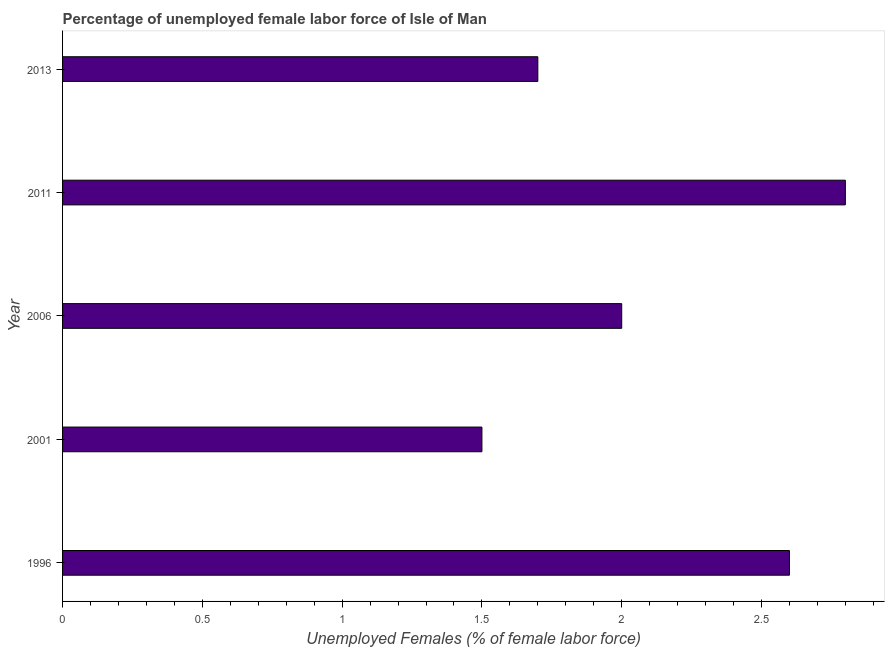What is the title of the graph?
Offer a very short reply. Percentage of unemployed female labor force of Isle of Man. What is the label or title of the X-axis?
Keep it short and to the point. Unemployed Females (% of female labor force). What is the total unemployed female labour force in 1996?
Provide a short and direct response. 2.6. Across all years, what is the maximum total unemployed female labour force?
Keep it short and to the point. 2.8. Across all years, what is the minimum total unemployed female labour force?
Provide a short and direct response. 1.5. In which year was the total unemployed female labour force maximum?
Provide a succinct answer. 2011. What is the sum of the total unemployed female labour force?
Provide a short and direct response. 10.6. What is the difference between the total unemployed female labour force in 1996 and 2001?
Give a very brief answer. 1.1. What is the average total unemployed female labour force per year?
Your response must be concise. 2.12. What is the ratio of the total unemployed female labour force in 2006 to that in 2011?
Make the answer very short. 0.71. Is the total unemployed female labour force in 2011 less than that in 2013?
Your response must be concise. No. Is the difference between the total unemployed female labour force in 1996 and 2001 greater than the difference between any two years?
Your answer should be very brief. No. Is the sum of the total unemployed female labour force in 2011 and 2013 greater than the maximum total unemployed female labour force across all years?
Offer a very short reply. Yes. In how many years, is the total unemployed female labour force greater than the average total unemployed female labour force taken over all years?
Provide a succinct answer. 2. How many bars are there?
Your answer should be very brief. 5. Are all the bars in the graph horizontal?
Your answer should be compact. Yes. What is the difference between two consecutive major ticks on the X-axis?
Offer a very short reply. 0.5. What is the Unemployed Females (% of female labor force) of 1996?
Offer a very short reply. 2.6. What is the Unemployed Females (% of female labor force) of 2011?
Your answer should be very brief. 2.8. What is the Unemployed Females (% of female labor force) of 2013?
Provide a succinct answer. 1.7. What is the difference between the Unemployed Females (% of female labor force) in 1996 and 2001?
Ensure brevity in your answer.  1.1. What is the difference between the Unemployed Females (% of female labor force) in 1996 and 2006?
Provide a short and direct response. 0.6. What is the difference between the Unemployed Females (% of female labor force) in 1996 and 2011?
Give a very brief answer. -0.2. What is the difference between the Unemployed Females (% of female labor force) in 2001 and 2006?
Your response must be concise. -0.5. What is the difference between the Unemployed Females (% of female labor force) in 2001 and 2011?
Keep it short and to the point. -1.3. What is the difference between the Unemployed Females (% of female labor force) in 2006 and 2011?
Provide a succinct answer. -0.8. What is the difference between the Unemployed Females (% of female labor force) in 2006 and 2013?
Your answer should be compact. 0.3. What is the difference between the Unemployed Females (% of female labor force) in 2011 and 2013?
Provide a succinct answer. 1.1. What is the ratio of the Unemployed Females (% of female labor force) in 1996 to that in 2001?
Your answer should be compact. 1.73. What is the ratio of the Unemployed Females (% of female labor force) in 1996 to that in 2011?
Keep it short and to the point. 0.93. What is the ratio of the Unemployed Females (% of female labor force) in 1996 to that in 2013?
Offer a very short reply. 1.53. What is the ratio of the Unemployed Females (% of female labor force) in 2001 to that in 2006?
Keep it short and to the point. 0.75. What is the ratio of the Unemployed Females (% of female labor force) in 2001 to that in 2011?
Offer a terse response. 0.54. What is the ratio of the Unemployed Females (% of female labor force) in 2001 to that in 2013?
Provide a succinct answer. 0.88. What is the ratio of the Unemployed Females (% of female labor force) in 2006 to that in 2011?
Your response must be concise. 0.71. What is the ratio of the Unemployed Females (% of female labor force) in 2006 to that in 2013?
Provide a succinct answer. 1.18. What is the ratio of the Unemployed Females (% of female labor force) in 2011 to that in 2013?
Keep it short and to the point. 1.65. 